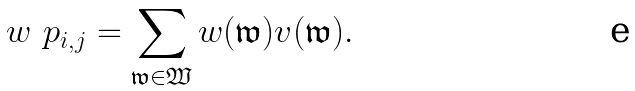<formula> <loc_0><loc_0><loc_500><loc_500>w \ p _ { i , j } = \sum _ { \mathfrak w \in \mathfrak W } w ( \mathfrak w ) v ( \mathfrak w ) .</formula> 